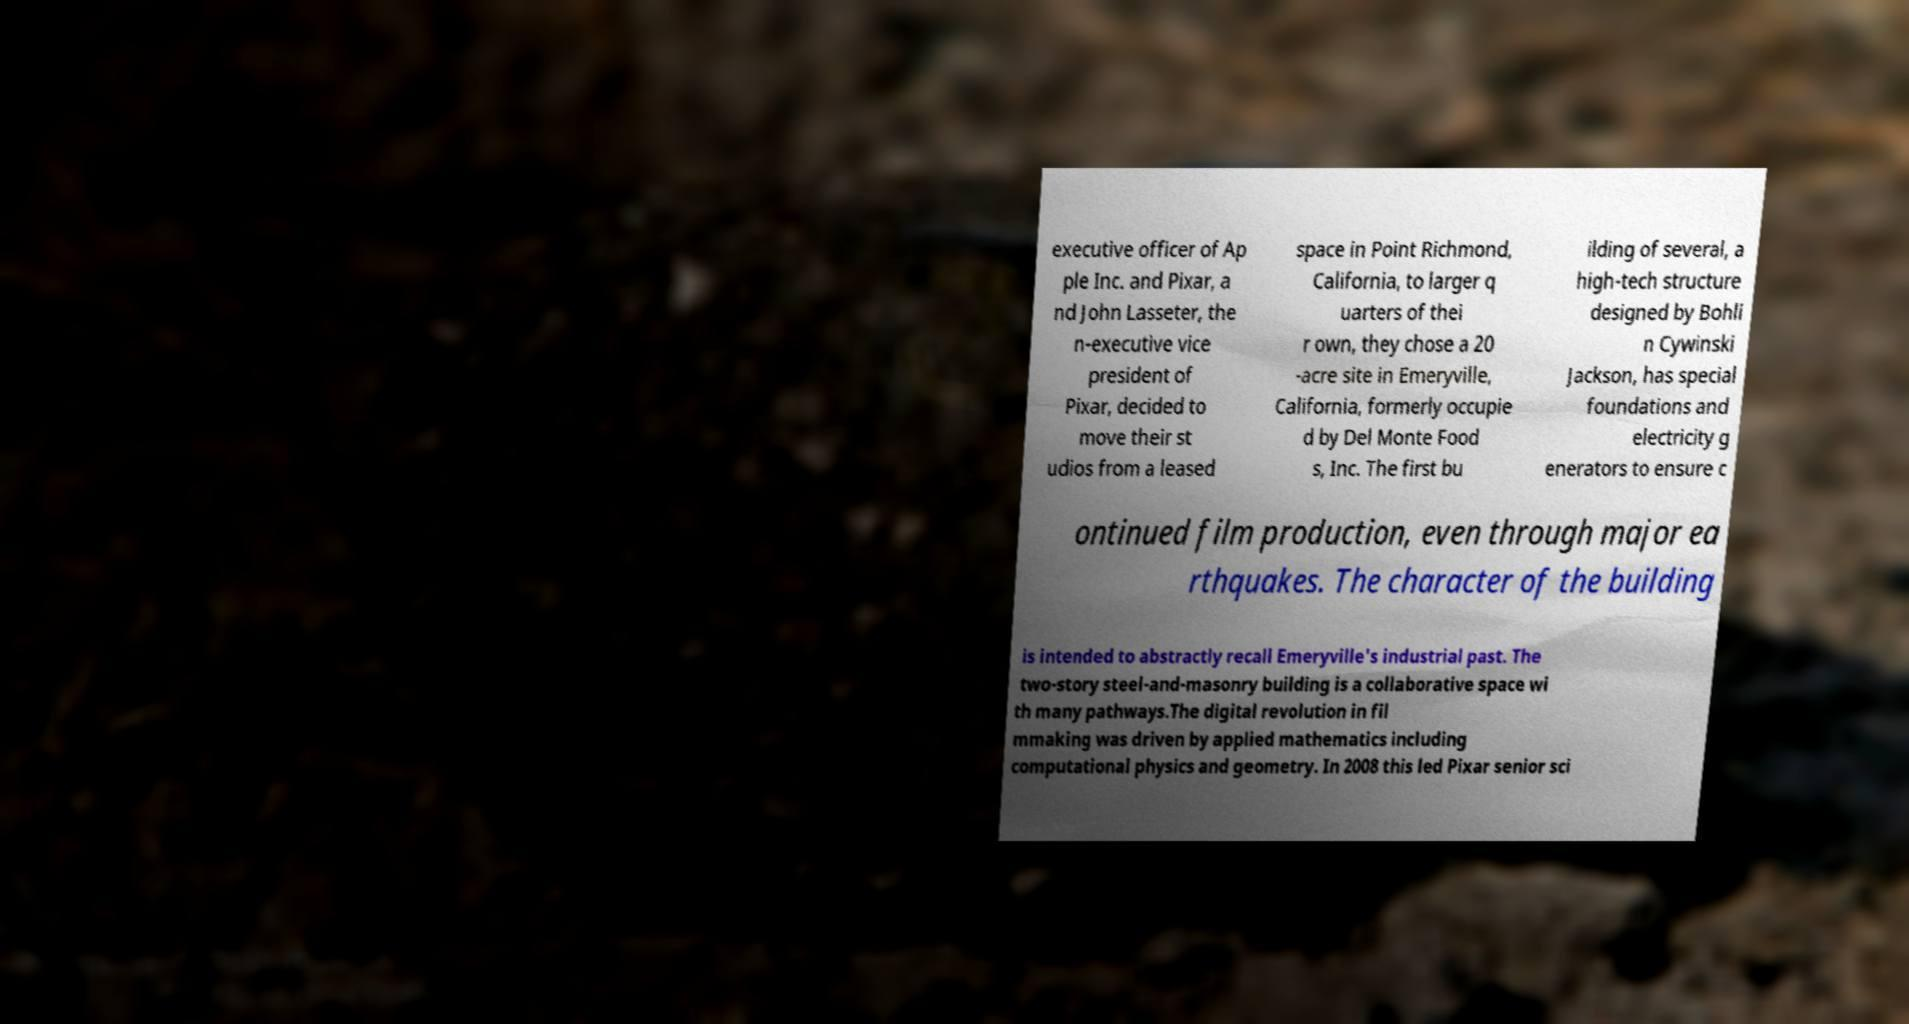For documentation purposes, I need the text within this image transcribed. Could you provide that? executive officer of Ap ple Inc. and Pixar, a nd John Lasseter, the n-executive vice president of Pixar, decided to move their st udios from a leased space in Point Richmond, California, to larger q uarters of thei r own, they chose a 20 -acre site in Emeryville, California, formerly occupie d by Del Monte Food s, Inc. The first bu ilding of several, a high-tech structure designed by Bohli n Cywinski Jackson, has special foundations and electricity g enerators to ensure c ontinued film production, even through major ea rthquakes. The character of the building is intended to abstractly recall Emeryville's industrial past. The two-story steel-and-masonry building is a collaborative space wi th many pathways.The digital revolution in fil mmaking was driven by applied mathematics including computational physics and geometry. In 2008 this led Pixar senior sci 